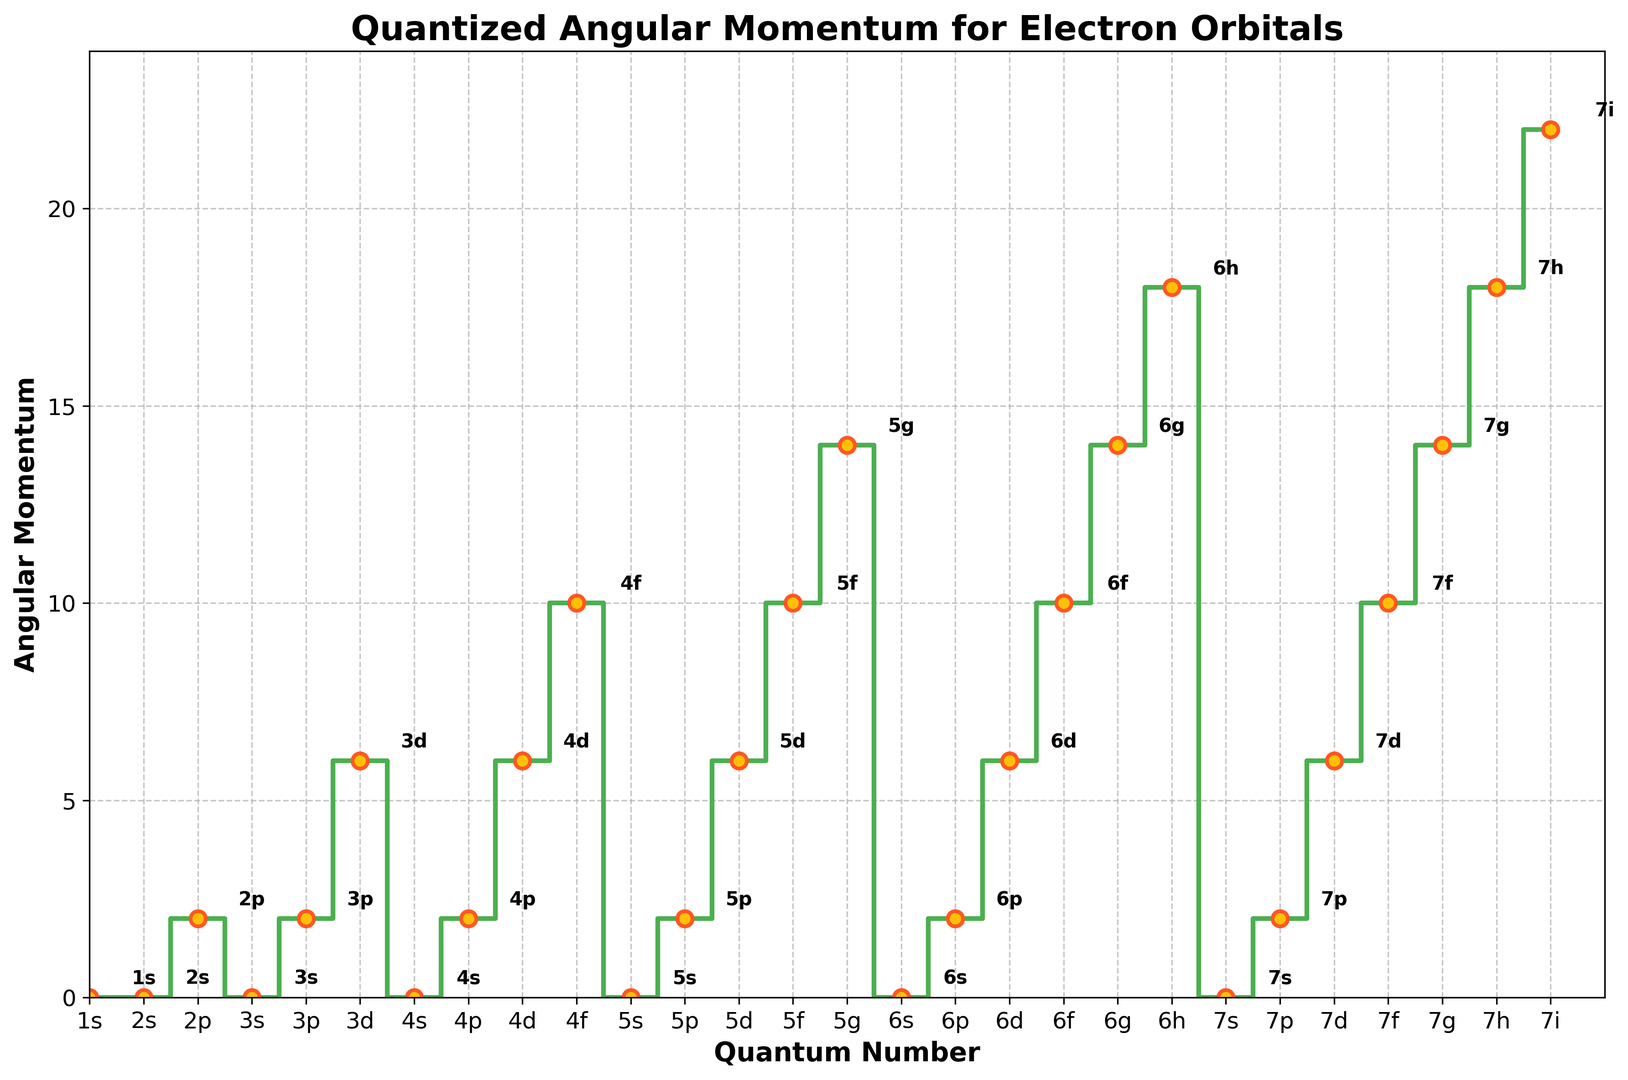What is the angular momentum value for the 2p orbital? Locate the point corresponding to the 2p orbital. The y-coordinate of this point represents the angular momentum value.
Answer: 2 Which orbital has the highest angular momentum in the dataset? Identify the point with the maximum y-coordinate value. The quantum number of this point is the highest angular momentum.
Answer: 7i Is the angular momentum of the 3d orbital greater than the angular momentum of the 4p orbital? Compare the y-coordinates of the 3d and 4p orbitals.
Answer: Yes What is the average angular momentum of the orbitals with n=4? Find all y-coordinates for orbitals where n=4 (0, 2, 6, 10). Sum these values and divide by the number of orbitals (4). (0 + 2 + 6 + 10) / 4 = 18 / 4 = 4.5
Answer: 4.5 Between which orbitals does the largest increase in angular momentum occur? Identify the pair of consecutive points with the largest difference in their y-coordinates.
Answer: Between 4d and 4f How many orbitals have an angular momentum of 10? Count the points with a y-coordinate value of 10.
Answer: 4 What is the sum of the angular momentum values for orbitals with n=5? Find and sum all y-coordinates for orbitals where n=5 (0, 2, 6, 10, 14). (0 + 2 + 6 + 10 + 14)
Answer: 32 Does the angular momentum value always increase as n increases? Observe the trend of y-coordinates as the quantum number n increases, noting any decreases.
Answer: No What is the angular momentum value for the orbital with the quantum number labeled as 6h? Locate the point corresponding to the orbital labeled as 6h. The y-coordinate of this point represents the angular momentum value.
Answer: 18 Which color is used to highlight the markers on the plot? Observe the color used for the markers on the displayed plot.
Answer: Yellow 